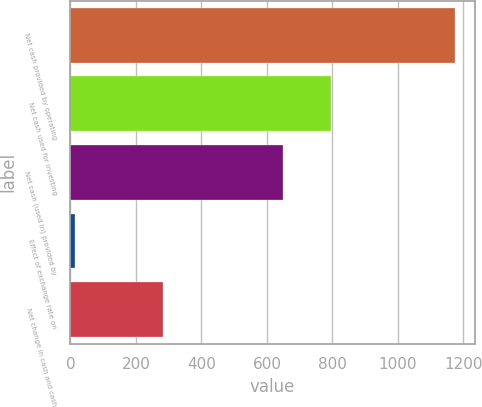<chart> <loc_0><loc_0><loc_500><loc_500><bar_chart><fcel>Net cash provided by operating<fcel>Net cash used for investing<fcel>Net cash (used in) provided by<fcel>Effect of exchange rate on<fcel>Net change in cash and cash<nl><fcel>1175.9<fcel>795.7<fcel>649.8<fcel>13.2<fcel>282.8<nl></chart> 